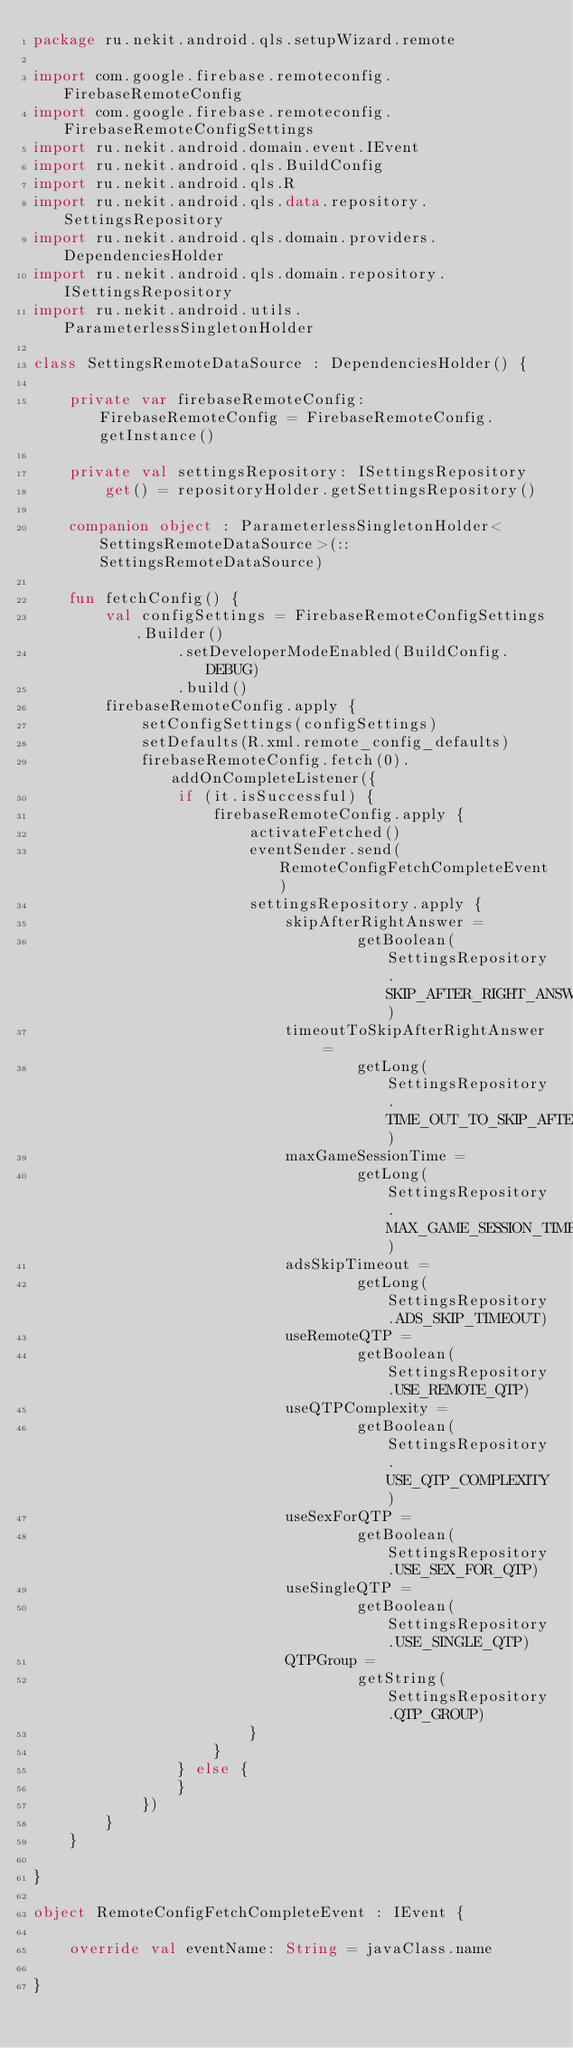<code> <loc_0><loc_0><loc_500><loc_500><_Kotlin_>package ru.nekit.android.qls.setupWizard.remote

import com.google.firebase.remoteconfig.FirebaseRemoteConfig
import com.google.firebase.remoteconfig.FirebaseRemoteConfigSettings
import ru.nekit.android.domain.event.IEvent
import ru.nekit.android.qls.BuildConfig
import ru.nekit.android.qls.R
import ru.nekit.android.qls.data.repository.SettingsRepository
import ru.nekit.android.qls.domain.providers.DependenciesHolder
import ru.nekit.android.qls.domain.repository.ISettingsRepository
import ru.nekit.android.utils.ParameterlessSingletonHolder

class SettingsRemoteDataSource : DependenciesHolder() {

    private var firebaseRemoteConfig: FirebaseRemoteConfig = FirebaseRemoteConfig.getInstance()

    private val settingsRepository: ISettingsRepository
        get() = repositoryHolder.getSettingsRepository()

    companion object : ParameterlessSingletonHolder<SettingsRemoteDataSource>(::SettingsRemoteDataSource)

    fun fetchConfig() {
        val configSettings = FirebaseRemoteConfigSettings.Builder()
                .setDeveloperModeEnabled(BuildConfig.DEBUG)
                .build()
        firebaseRemoteConfig.apply {
            setConfigSettings(configSettings)
            setDefaults(R.xml.remote_config_defaults)
            firebaseRemoteConfig.fetch(0).addOnCompleteListener({
                if (it.isSuccessful) {
                    firebaseRemoteConfig.apply {
                        activateFetched()
                        eventSender.send(RemoteConfigFetchCompleteEvent)
                        settingsRepository.apply {
                            skipAfterRightAnswer =
                                    getBoolean(SettingsRepository.SKIP_AFTER_RIGHT_ANSWER)
                            timeoutToSkipAfterRightAnswer =
                                    getLong(SettingsRepository.TIME_OUT_TO_SKIP_AFTER_RIGHT_ANSWER)
                            maxGameSessionTime =
                                    getLong(SettingsRepository.MAX_GAME_SESSION_TIME)
                            adsSkipTimeout =
                                    getLong(SettingsRepository.ADS_SKIP_TIMEOUT)
                            useRemoteQTP =
                                    getBoolean(SettingsRepository.USE_REMOTE_QTP)
                            useQTPComplexity =
                                    getBoolean(SettingsRepository.USE_QTP_COMPLEXITY)
                            useSexForQTP =
                                    getBoolean(SettingsRepository.USE_SEX_FOR_QTP)
                            useSingleQTP =
                                    getBoolean(SettingsRepository.USE_SINGLE_QTP)
                            QTPGroup =
                                    getString(SettingsRepository.QTP_GROUP)
                        }
                    }
                } else {
                }
            })
        }
    }

}

object RemoteConfigFetchCompleteEvent : IEvent {

    override val eventName: String = javaClass.name

}</code> 